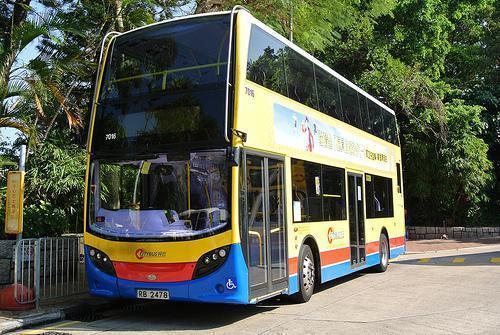How many tires are able to be seen?
Give a very brief answer. 2. How many levels are on the bus?
Give a very brief answer. 2. How many sets of doors on the bus can be seen?
Give a very brief answer. 2. 